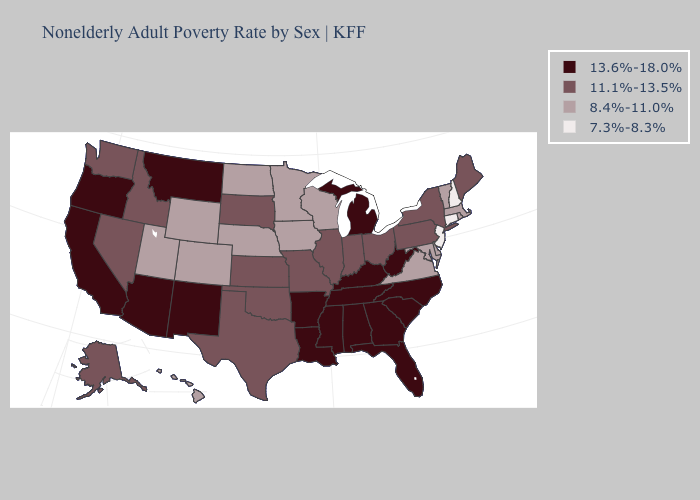Name the states that have a value in the range 7.3%-8.3%?
Keep it brief. Connecticut, New Hampshire, New Jersey. Which states hav the highest value in the West?
Give a very brief answer. Arizona, California, Montana, New Mexico, Oregon. Does South Dakota have a lower value than Ohio?
Short answer required. No. What is the value of Texas?
Be succinct. 11.1%-13.5%. What is the value of Alaska?
Give a very brief answer. 11.1%-13.5%. What is the highest value in the Northeast ?
Keep it brief. 11.1%-13.5%. What is the value of Wyoming?
Keep it brief. 8.4%-11.0%. What is the value of Vermont?
Write a very short answer. 8.4%-11.0%. What is the value of Delaware?
Give a very brief answer. 8.4%-11.0%. Among the states that border Washington , which have the lowest value?
Quick response, please. Idaho. Does Tennessee have the highest value in the USA?
Short answer required. Yes. Name the states that have a value in the range 11.1%-13.5%?
Answer briefly. Alaska, Idaho, Illinois, Indiana, Kansas, Maine, Missouri, Nevada, New York, Ohio, Oklahoma, Pennsylvania, South Dakota, Texas, Washington. Name the states that have a value in the range 11.1%-13.5%?
Be succinct. Alaska, Idaho, Illinois, Indiana, Kansas, Maine, Missouri, Nevada, New York, Ohio, Oklahoma, Pennsylvania, South Dakota, Texas, Washington. What is the value of Montana?
Give a very brief answer. 13.6%-18.0%. Does Arkansas have the highest value in the USA?
Be succinct. Yes. 